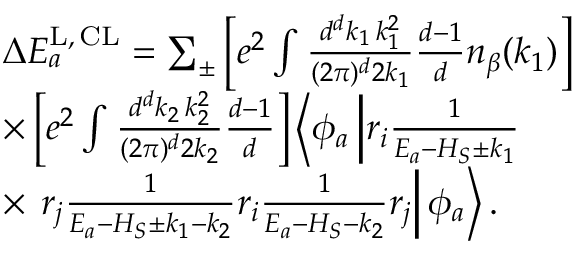Convert formula to latex. <formula><loc_0><loc_0><loc_500><loc_500>\begin{array} { r l } & { \Delta E _ { a } ^ { L , \, C L } = \sum _ { \pm } \left [ e ^ { 2 } \int \frac { d ^ { d } k _ { 1 } \, k _ { 1 } ^ { 2 } } { ( 2 \pi ) ^ { d } 2 k _ { 1 } } \frac { d - 1 } { d } n _ { \beta } ( k _ { 1 } ) \right ] } \\ & { \times \left [ e ^ { 2 } \int \frac { d ^ { d } k _ { 2 } \, k _ { 2 } ^ { 2 } } { ( 2 \pi ) ^ { d } 2 k _ { 2 } } \frac { d - 1 } { d } \right ] \left \langle \phi _ { a } \left | r _ { i } \frac { 1 } { E _ { a } - H _ { S } \pm k _ { 1 } } } \\ & { \times r _ { j } \frac { 1 } { E _ { a } - H _ { S } \pm k _ { 1 } - k _ { 2 } } r _ { i } \frac { 1 } { E _ { a } - H _ { S } - k _ { 2 } } r _ { j } \right | \phi _ { a } \right \rangle . } \end{array}</formula> 